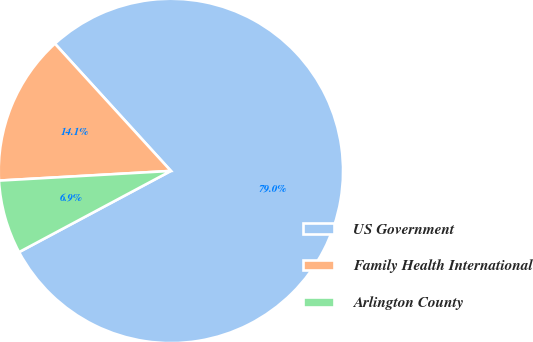Convert chart. <chart><loc_0><loc_0><loc_500><loc_500><pie_chart><fcel>US Government<fcel>Family Health International<fcel>Arlington County<nl><fcel>78.95%<fcel>14.13%<fcel>6.92%<nl></chart> 